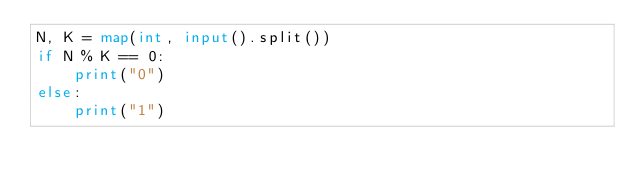<code> <loc_0><loc_0><loc_500><loc_500><_Python_>N, K = map(int, input().split())
if N % K == 0:
    print("0")
else:
    print("1")
</code> 